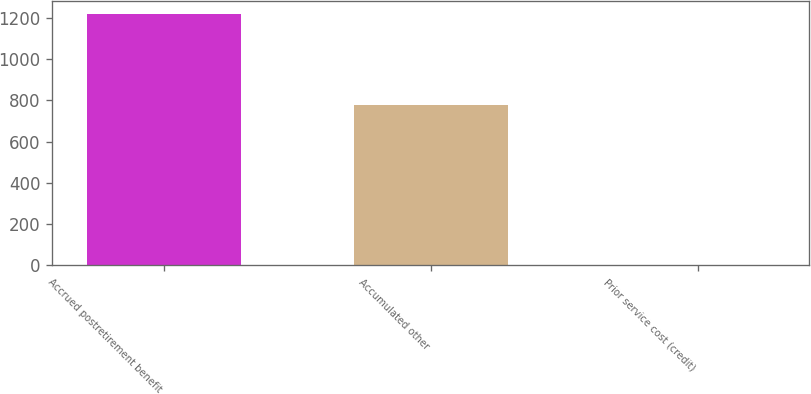Convert chart to OTSL. <chart><loc_0><loc_0><loc_500><loc_500><bar_chart><fcel>Accrued postretirement benefit<fcel>Accumulated other<fcel>Prior service cost (credit)<nl><fcel>1220<fcel>777<fcel>3<nl></chart> 